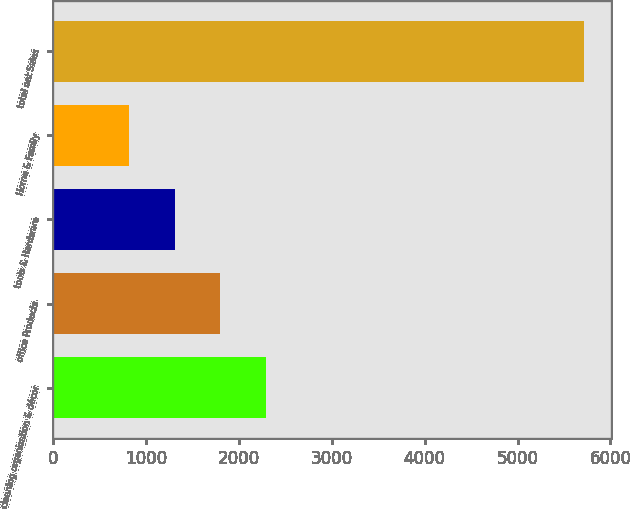<chart> <loc_0><loc_0><loc_500><loc_500><bar_chart><fcel>cleaning organization & décor<fcel>office Products<fcel>tools & Hardware<fcel>Home & Family<fcel>total net Sales<nl><fcel>2290.98<fcel>1801.52<fcel>1312.06<fcel>822.6<fcel>5717.2<nl></chart> 